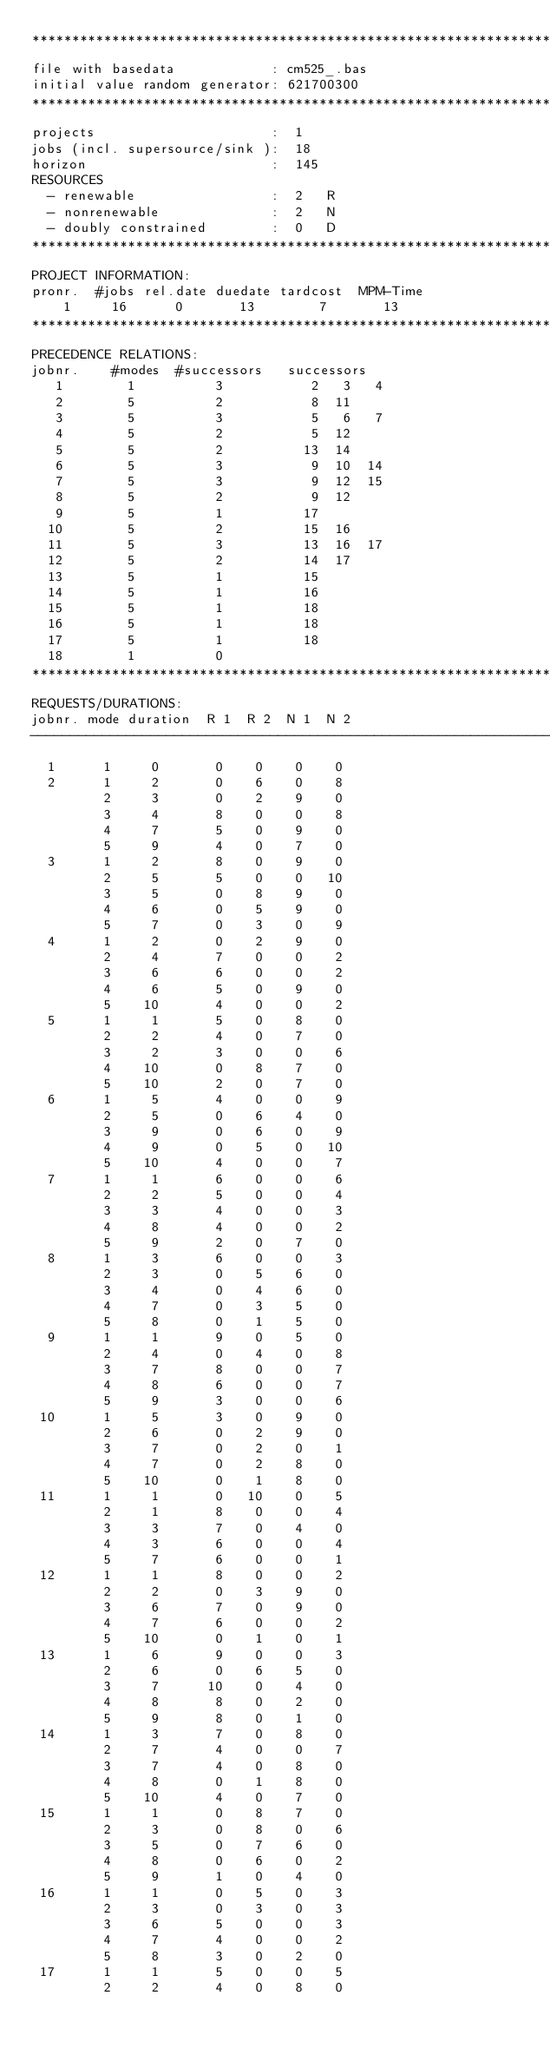Convert code to text. <code><loc_0><loc_0><loc_500><loc_500><_ObjectiveC_>************************************************************************
file with basedata            : cm525_.bas
initial value random generator: 621700300
************************************************************************
projects                      :  1
jobs (incl. supersource/sink ):  18
horizon                       :  145
RESOURCES
  - renewable                 :  2   R
  - nonrenewable              :  2   N
  - doubly constrained        :  0   D
************************************************************************
PROJECT INFORMATION:
pronr.  #jobs rel.date duedate tardcost  MPM-Time
    1     16      0       13        7       13
************************************************************************
PRECEDENCE RELATIONS:
jobnr.    #modes  #successors   successors
   1        1          3           2   3   4
   2        5          2           8  11
   3        5          3           5   6   7
   4        5          2           5  12
   5        5          2          13  14
   6        5          3           9  10  14
   7        5          3           9  12  15
   8        5          2           9  12
   9        5          1          17
  10        5          2          15  16
  11        5          3          13  16  17
  12        5          2          14  17
  13        5          1          15
  14        5          1          16
  15        5          1          18
  16        5          1          18
  17        5          1          18
  18        1          0        
************************************************************************
REQUESTS/DURATIONS:
jobnr. mode duration  R 1  R 2  N 1  N 2
------------------------------------------------------------------------
  1      1     0       0    0    0    0
  2      1     2       0    6    0    8
         2     3       0    2    9    0
         3     4       8    0    0    8
         4     7       5    0    9    0
         5     9       4    0    7    0
  3      1     2       8    0    9    0
         2     5       5    0    0   10
         3     5       0    8    9    0
         4     6       0    5    9    0
         5     7       0    3    0    9
  4      1     2       0    2    9    0
         2     4       7    0    0    2
         3     6       6    0    0    2
         4     6       5    0    9    0
         5    10       4    0    0    2
  5      1     1       5    0    8    0
         2     2       4    0    7    0
         3     2       3    0    0    6
         4    10       0    8    7    0
         5    10       2    0    7    0
  6      1     5       4    0    0    9
         2     5       0    6    4    0
         3     9       0    6    0    9
         4     9       0    5    0   10
         5    10       4    0    0    7
  7      1     1       6    0    0    6
         2     2       5    0    0    4
         3     3       4    0    0    3
         4     8       4    0    0    2
         5     9       2    0    7    0
  8      1     3       6    0    0    3
         2     3       0    5    6    0
         3     4       0    4    6    0
         4     7       0    3    5    0
         5     8       0    1    5    0
  9      1     1       9    0    5    0
         2     4       0    4    0    8
         3     7       8    0    0    7
         4     8       6    0    0    7
         5     9       3    0    0    6
 10      1     5       3    0    9    0
         2     6       0    2    9    0
         3     7       0    2    0    1
         4     7       0    2    8    0
         5    10       0    1    8    0
 11      1     1       0   10    0    5
         2     1       8    0    0    4
         3     3       7    0    4    0
         4     3       6    0    0    4
         5     7       6    0    0    1
 12      1     1       8    0    0    2
         2     2       0    3    9    0
         3     6       7    0    9    0
         4     7       6    0    0    2
         5    10       0    1    0    1
 13      1     6       9    0    0    3
         2     6       0    6    5    0
         3     7      10    0    4    0
         4     8       8    0    2    0
         5     9       8    0    1    0
 14      1     3       7    0    8    0
         2     7       4    0    0    7
         3     7       4    0    8    0
         4     8       0    1    8    0
         5    10       4    0    7    0
 15      1     1       0    8    7    0
         2     3       0    8    0    6
         3     5       0    7    6    0
         4     8       0    6    0    2
         5     9       1    0    4    0
 16      1     1       0    5    0    3
         2     3       0    3    0    3
         3     6       5    0    0    3
         4     7       4    0    0    2
         5     8       3    0    2    0
 17      1     1       5    0    0    5
         2     2       4    0    8    0</code> 